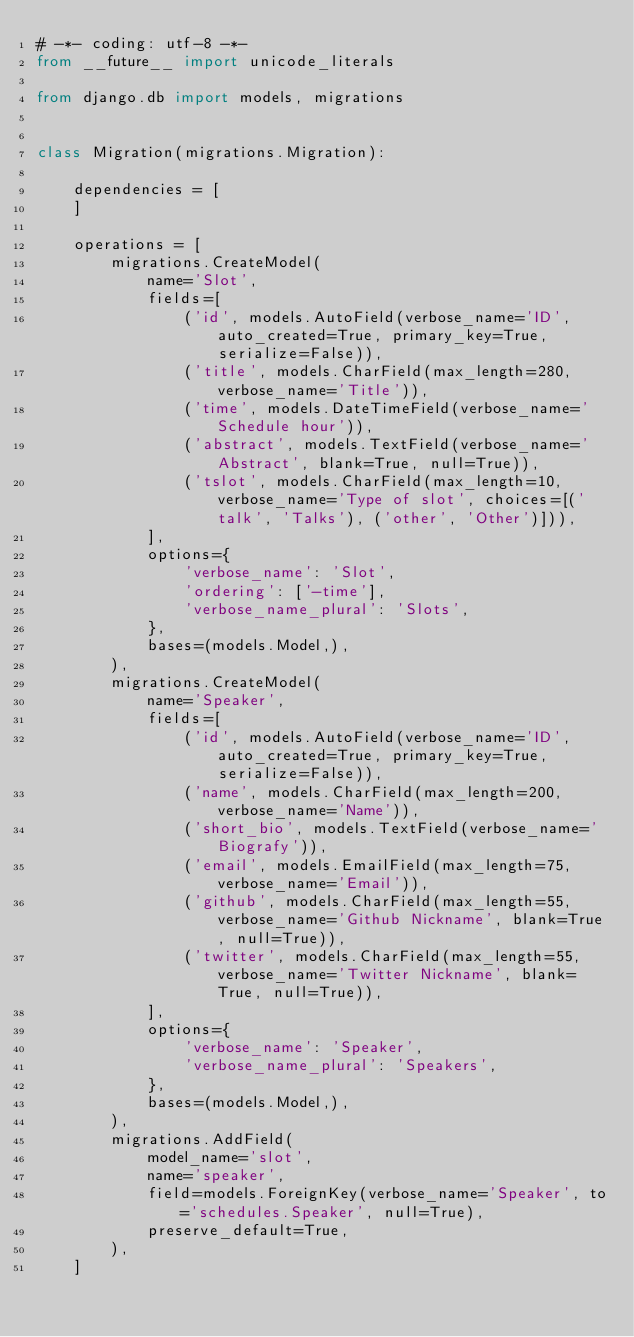<code> <loc_0><loc_0><loc_500><loc_500><_Python_># -*- coding: utf-8 -*-
from __future__ import unicode_literals

from django.db import models, migrations


class Migration(migrations.Migration):

    dependencies = [
    ]

    operations = [
        migrations.CreateModel(
            name='Slot',
            fields=[
                ('id', models.AutoField(verbose_name='ID', auto_created=True, primary_key=True, serialize=False)),
                ('title', models.CharField(max_length=280, verbose_name='Title')),
                ('time', models.DateTimeField(verbose_name='Schedule hour')),
                ('abstract', models.TextField(verbose_name='Abstract', blank=True, null=True)),
                ('tslot', models.CharField(max_length=10, verbose_name='Type of slot', choices=[('talk', 'Talks'), ('other', 'Other')])),
            ],
            options={
                'verbose_name': 'Slot',
                'ordering': ['-time'],
                'verbose_name_plural': 'Slots',
            },
            bases=(models.Model,),
        ),
        migrations.CreateModel(
            name='Speaker',
            fields=[
                ('id', models.AutoField(verbose_name='ID', auto_created=True, primary_key=True, serialize=False)),
                ('name', models.CharField(max_length=200, verbose_name='Name')),
                ('short_bio', models.TextField(verbose_name='Biografy')),
                ('email', models.EmailField(max_length=75, verbose_name='Email')),
                ('github', models.CharField(max_length=55, verbose_name='Github Nickname', blank=True, null=True)),
                ('twitter', models.CharField(max_length=55, verbose_name='Twitter Nickname', blank=True, null=True)),
            ],
            options={
                'verbose_name': 'Speaker',
                'verbose_name_plural': 'Speakers',
            },
            bases=(models.Model,),
        ),
        migrations.AddField(
            model_name='slot',
            name='speaker',
            field=models.ForeignKey(verbose_name='Speaker', to='schedules.Speaker', null=True),
            preserve_default=True,
        ),
    ]
</code> 